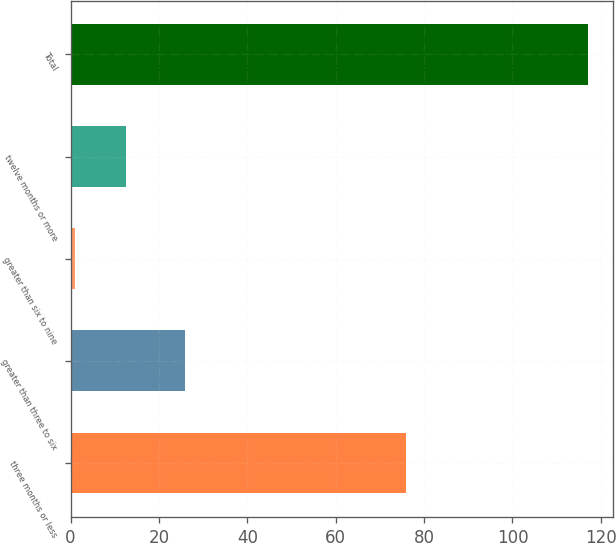Convert chart to OTSL. <chart><loc_0><loc_0><loc_500><loc_500><bar_chart><fcel>three months or less<fcel>greater than three to six<fcel>greater than six to nine<fcel>twelve months or more<fcel>Total<nl><fcel>76<fcel>26<fcel>1<fcel>12.6<fcel>117<nl></chart> 